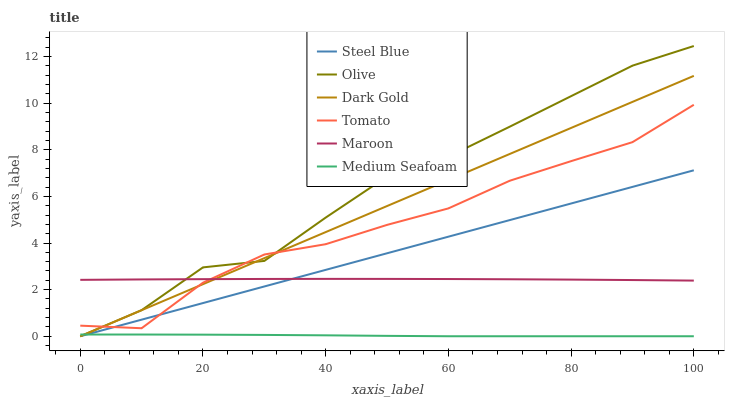Does Dark Gold have the minimum area under the curve?
Answer yes or no. No. Does Dark Gold have the maximum area under the curve?
Answer yes or no. No. Is Dark Gold the smoothest?
Answer yes or no. No. Is Dark Gold the roughest?
Answer yes or no. No. Does Maroon have the lowest value?
Answer yes or no. No. Does Dark Gold have the highest value?
Answer yes or no. No. Is Medium Seafoam less than Maroon?
Answer yes or no. Yes. Is Tomato greater than Medium Seafoam?
Answer yes or no. Yes. Does Medium Seafoam intersect Maroon?
Answer yes or no. No. 